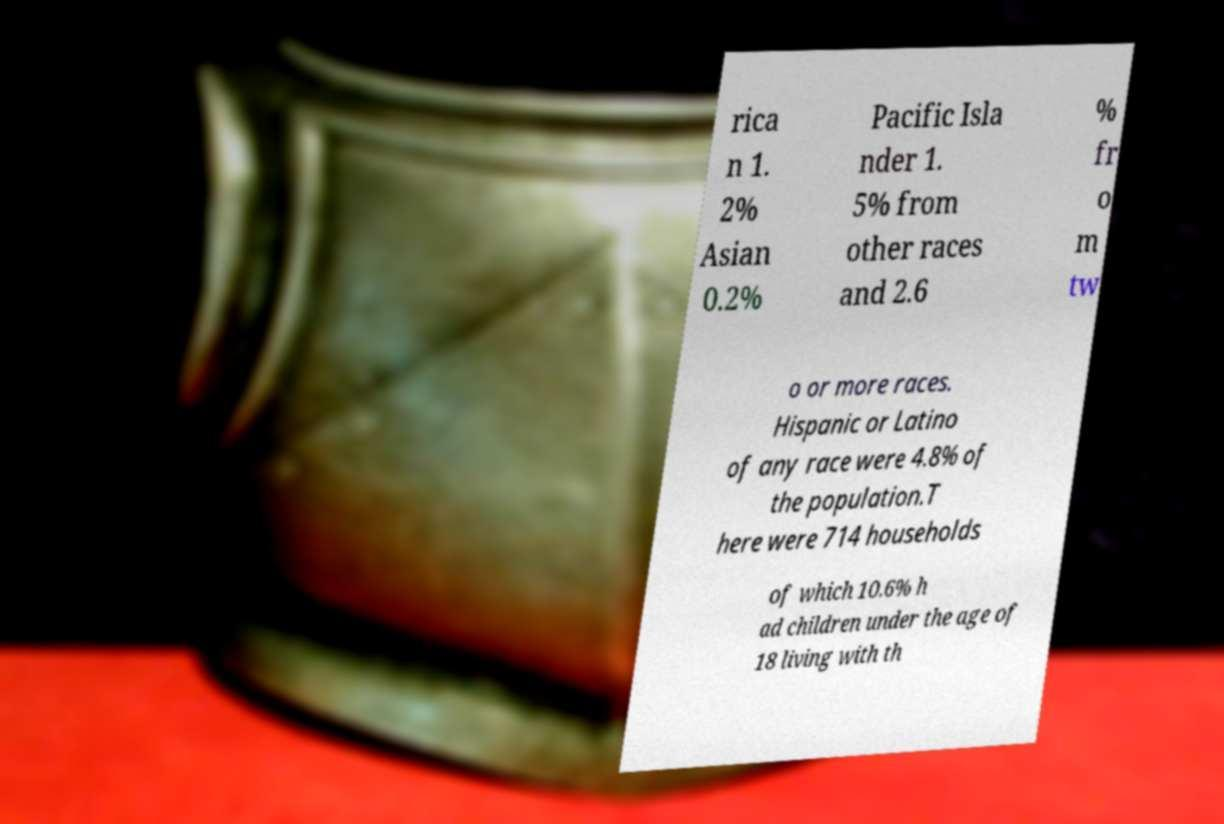Please identify and transcribe the text found in this image. rica n 1. 2% Asian 0.2% Pacific Isla nder 1. 5% from other races and 2.6 % fr o m tw o or more races. Hispanic or Latino of any race were 4.8% of the population.T here were 714 households of which 10.6% h ad children under the age of 18 living with th 